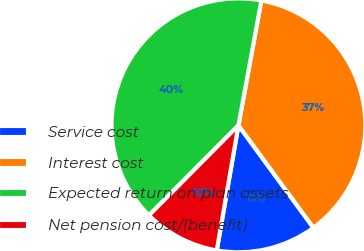<chart> <loc_0><loc_0><loc_500><loc_500><pie_chart><fcel>Service cost<fcel>Interest cost<fcel>Expected return on plan assets<fcel>Net pension cost/(benefit)<nl><fcel>12.79%<fcel>37.05%<fcel>40.44%<fcel>9.72%<nl></chart> 